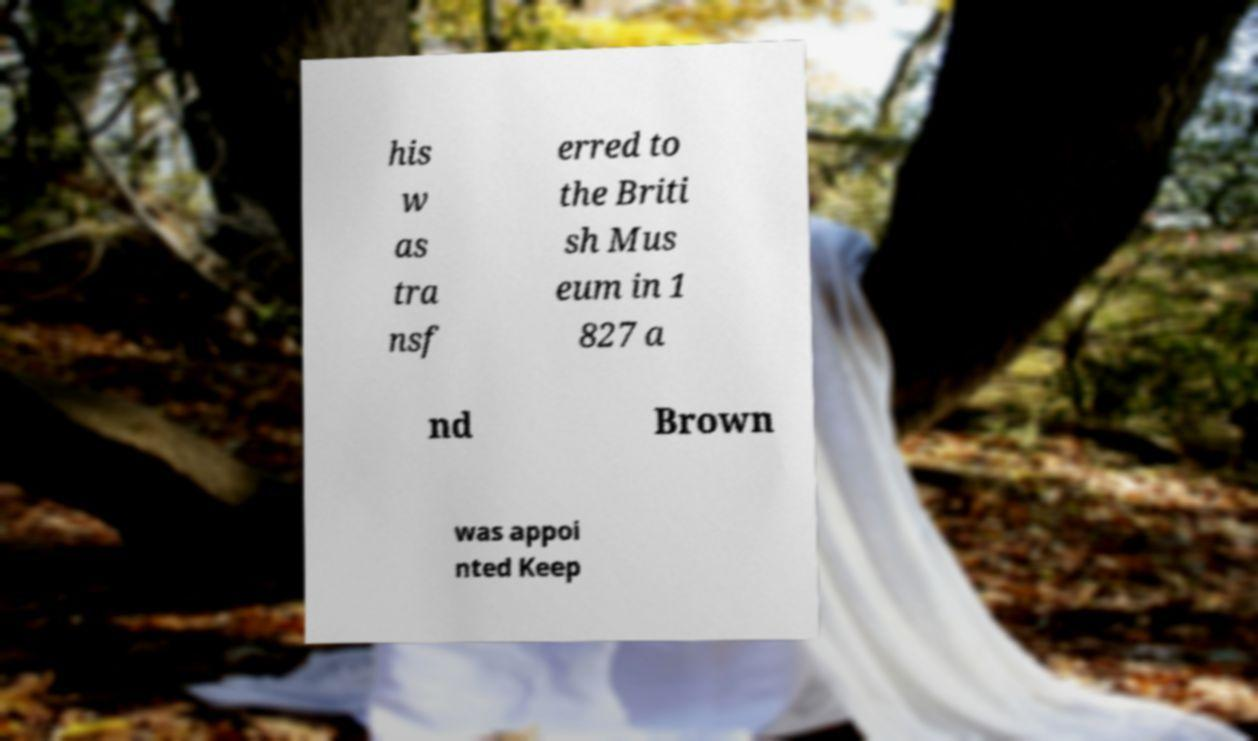Please read and relay the text visible in this image. What does it say? his w as tra nsf erred to the Briti sh Mus eum in 1 827 a nd Brown was appoi nted Keep 